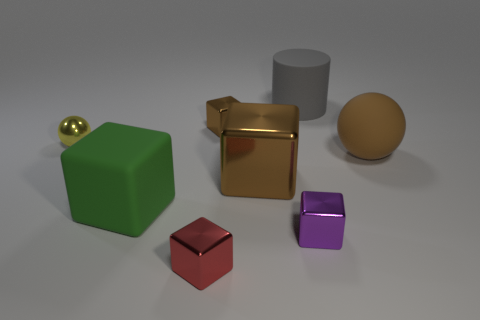Add 1 large gray matte objects. How many objects exist? 9 Subtract all rubber blocks. How many blocks are left? 4 Subtract all cylinders. How many objects are left? 7 Subtract 3 cubes. How many cubes are left? 2 Subtract all red balls. Subtract all green blocks. How many balls are left? 2 Subtract all purple balls. How many purple cylinders are left? 0 Subtract all cyan metallic cylinders. Subtract all red cubes. How many objects are left? 7 Add 1 large gray rubber cylinders. How many large gray rubber cylinders are left? 2 Add 8 tiny red cylinders. How many tiny red cylinders exist? 8 Subtract all purple cubes. How many cubes are left? 4 